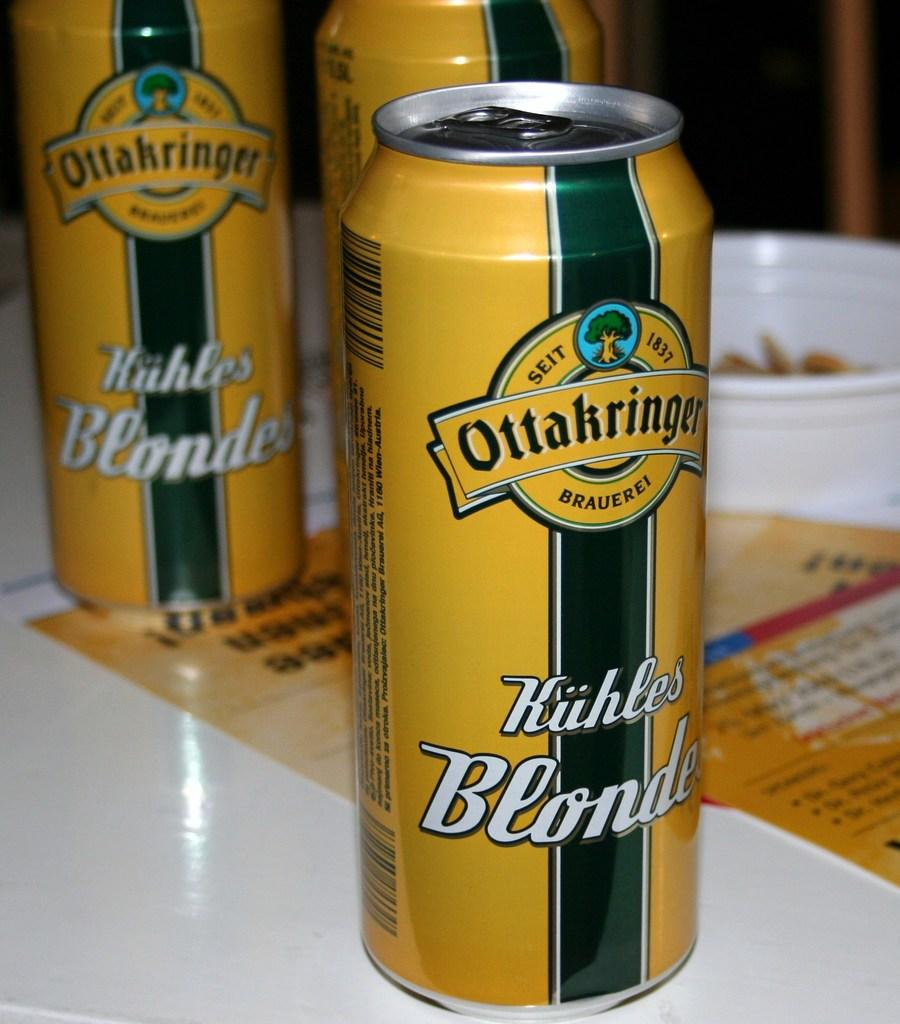<image>
Provide a brief description of the given image. Yellow and green beer can which says "Ottakringer" on it. 